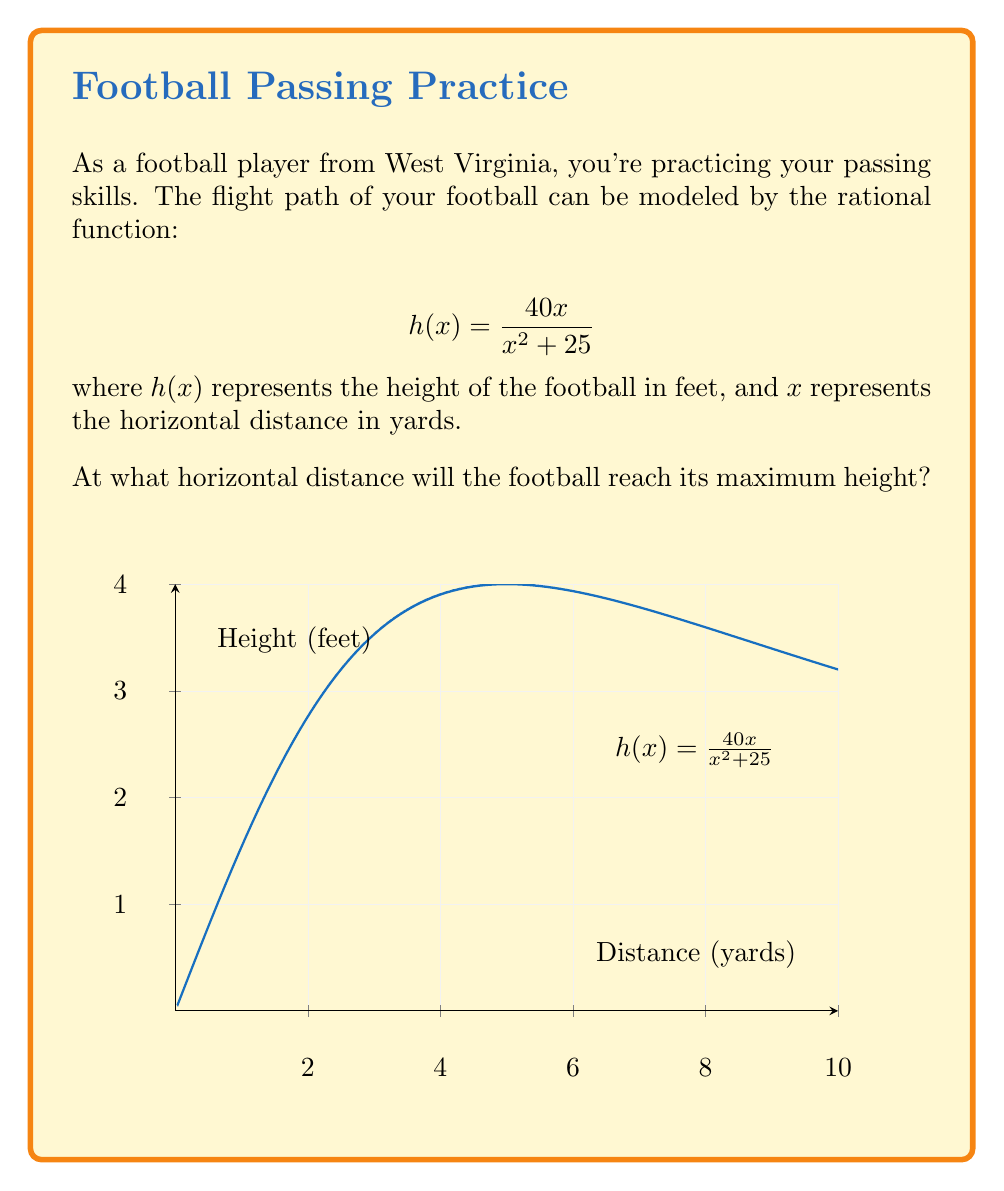Teach me how to tackle this problem. Let's approach this step-by-step:

1) To find the maximum height, we need to find the x-value where the derivative of $h(x)$ equals zero.

2) Let's find the derivative of $h(x)$ using the quotient rule:

   $$h'(x) = \frac{(x^2 + 25)(40) - 40x(2x)}{(x^2 + 25)^2}$$

3) Simplify the numerator:

   $$h'(x) = \frac{40x^2 + 1000 - 80x^2}{(x^2 + 25)^2} = \frac{1000 - 40x^2}{(x^2 + 25)^2}$$

4) Set $h'(x) = 0$ and solve for $x$:

   $$\frac{1000 - 40x^2}{(x^2 + 25)^2} = 0$$

5) The denominator is always positive, so the numerator must be zero:

   $$1000 - 40x^2 = 0$$
   $$40x^2 = 1000$$
   $$x^2 = 25$$
   $$x = \pm 5$$

6) Since we're dealing with distance, we take the positive value.

Therefore, the football will reach its maximum height when $x = 5$ yards.
Answer: 5 yards 